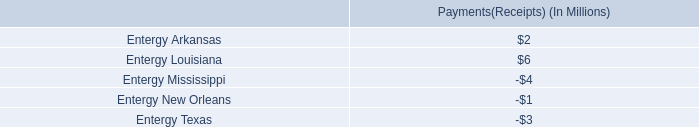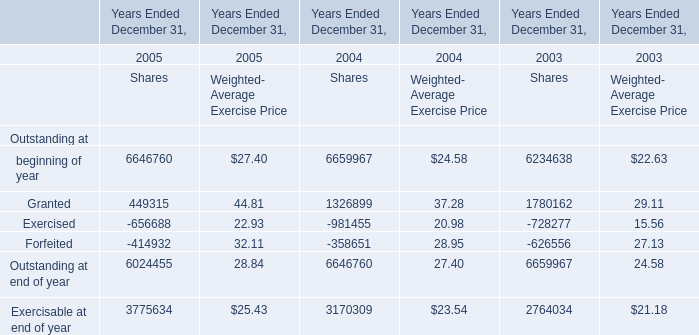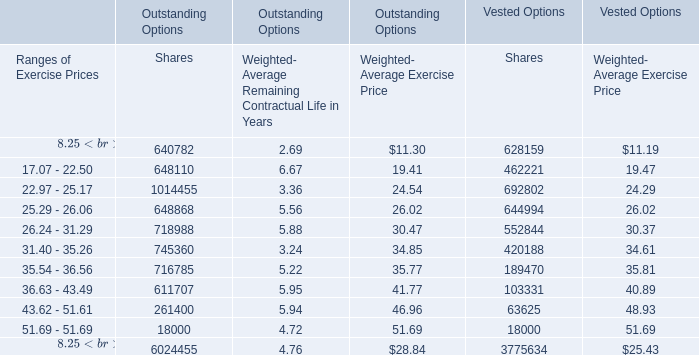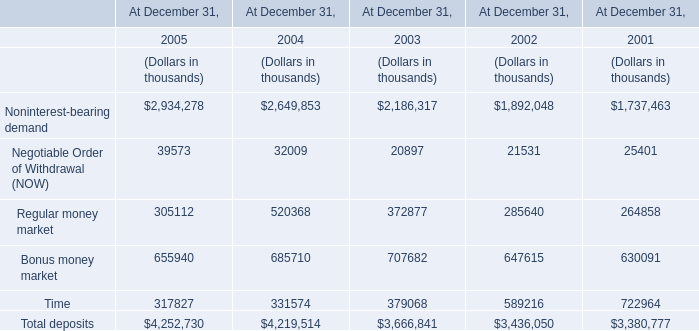Which year has the greatest proportion of beginning of year forWeighted- Average Exercise Price ? 
Answer: 2005. 